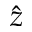Convert formula to latex. <formula><loc_0><loc_0><loc_500><loc_500>\hat { z }</formula> 